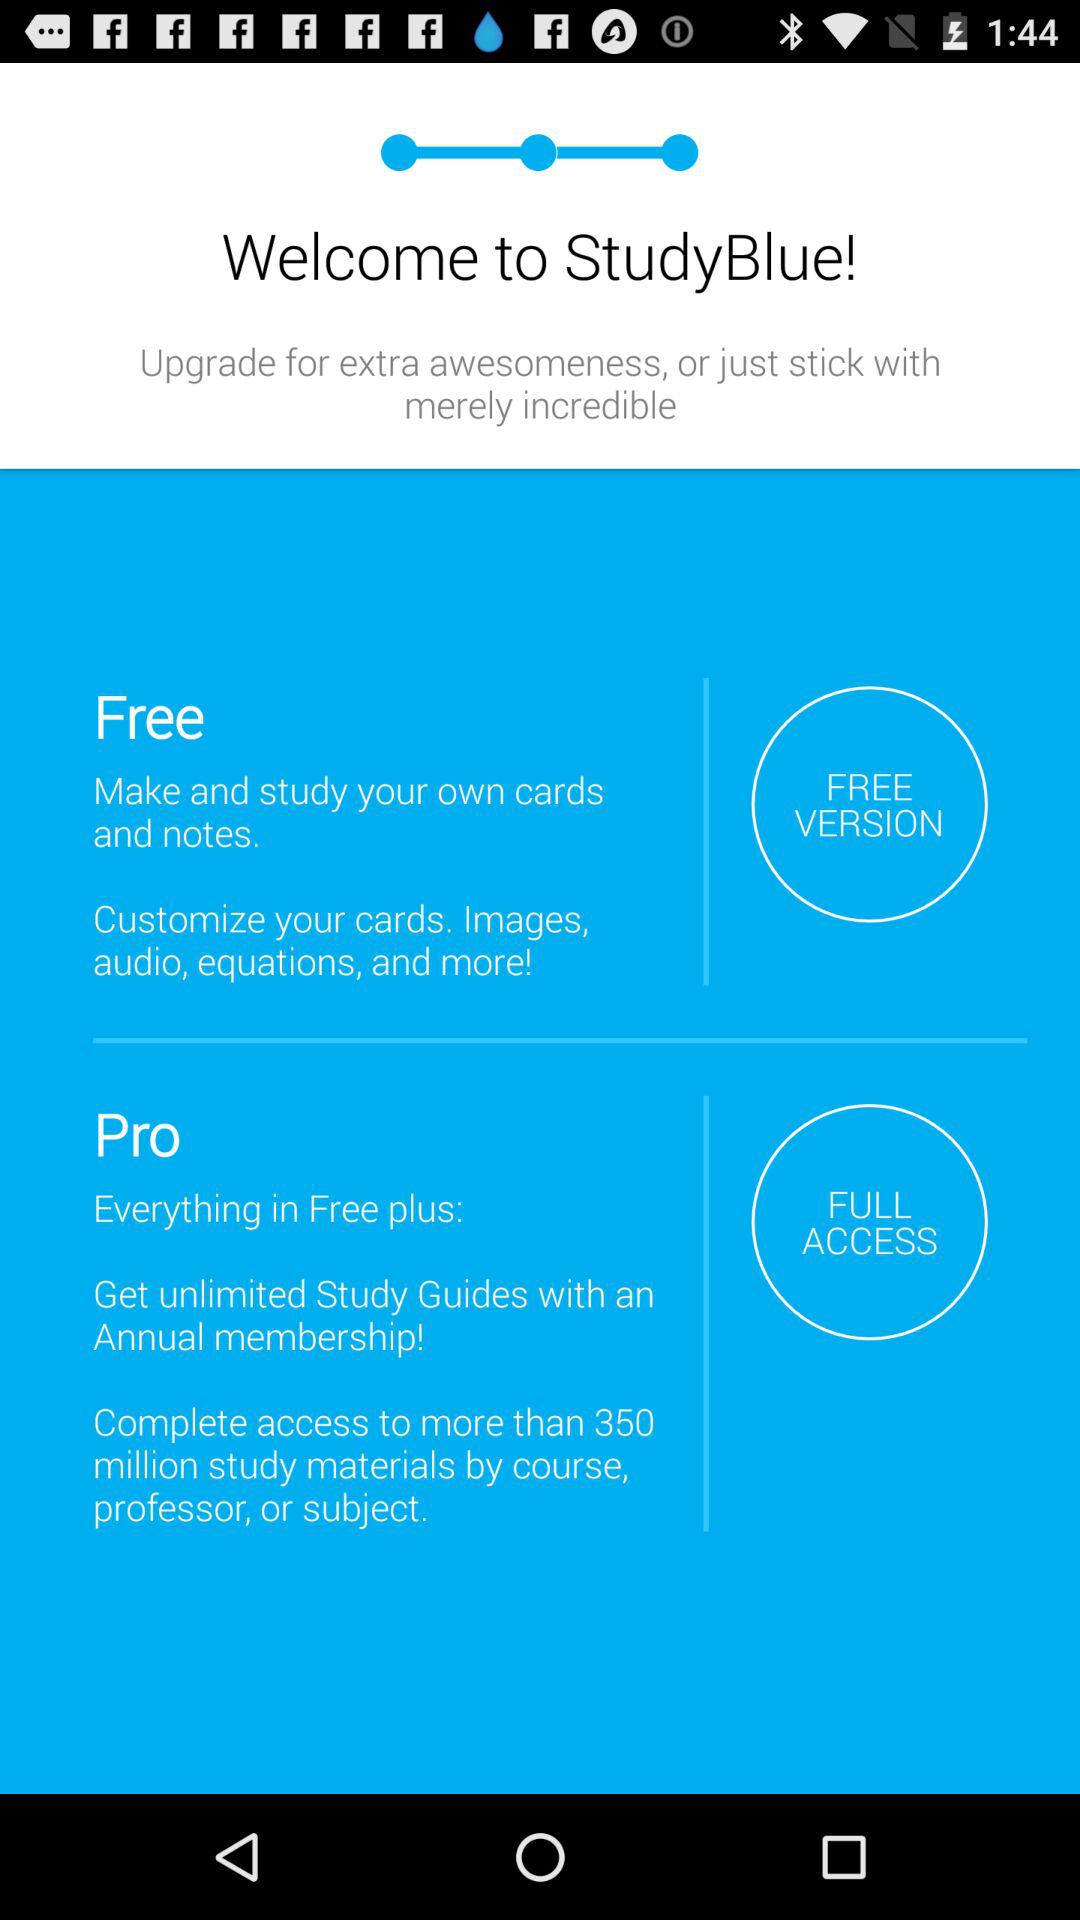How many more features does the Pro version have than the Free version?
Answer the question using a single word or phrase. 2 